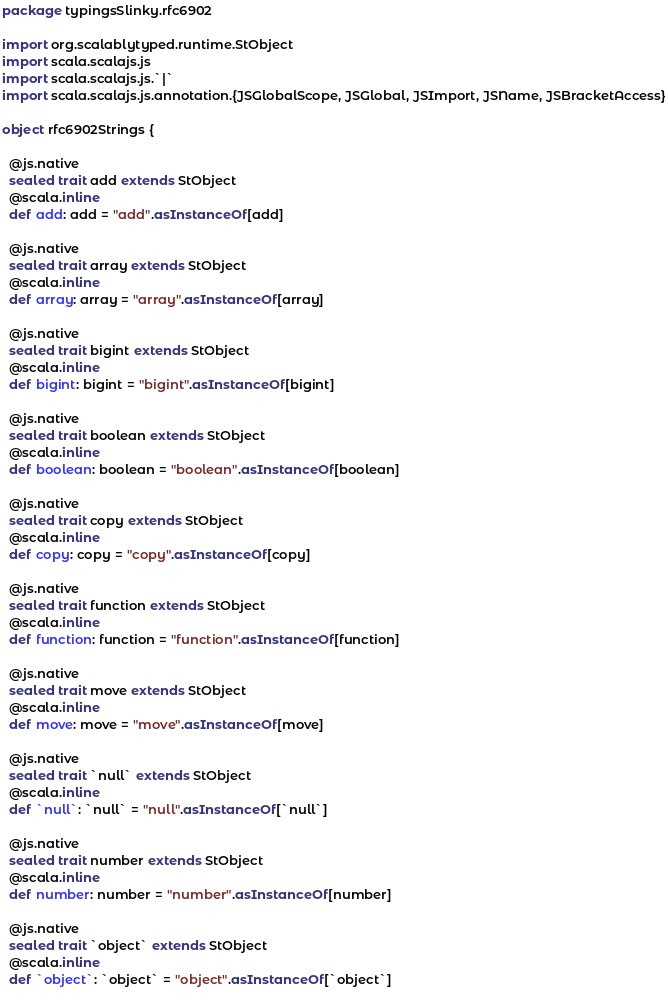<code> <loc_0><loc_0><loc_500><loc_500><_Scala_>package typingsSlinky.rfc6902

import org.scalablytyped.runtime.StObject
import scala.scalajs.js
import scala.scalajs.js.`|`
import scala.scalajs.js.annotation.{JSGlobalScope, JSGlobal, JSImport, JSName, JSBracketAccess}

object rfc6902Strings {
  
  @js.native
  sealed trait add extends StObject
  @scala.inline
  def add: add = "add".asInstanceOf[add]
  
  @js.native
  sealed trait array extends StObject
  @scala.inline
  def array: array = "array".asInstanceOf[array]
  
  @js.native
  sealed trait bigint extends StObject
  @scala.inline
  def bigint: bigint = "bigint".asInstanceOf[bigint]
  
  @js.native
  sealed trait boolean extends StObject
  @scala.inline
  def boolean: boolean = "boolean".asInstanceOf[boolean]
  
  @js.native
  sealed trait copy extends StObject
  @scala.inline
  def copy: copy = "copy".asInstanceOf[copy]
  
  @js.native
  sealed trait function extends StObject
  @scala.inline
  def function: function = "function".asInstanceOf[function]
  
  @js.native
  sealed trait move extends StObject
  @scala.inline
  def move: move = "move".asInstanceOf[move]
  
  @js.native
  sealed trait `null` extends StObject
  @scala.inline
  def `null`: `null` = "null".asInstanceOf[`null`]
  
  @js.native
  sealed trait number extends StObject
  @scala.inline
  def number: number = "number".asInstanceOf[number]
  
  @js.native
  sealed trait `object` extends StObject
  @scala.inline
  def `object`: `object` = "object".asInstanceOf[`object`]
  </code> 